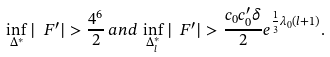<formula> <loc_0><loc_0><loc_500><loc_500>\inf _ { \Delta ^ { * } } | \ F ^ { \prime } | > \frac { 4 ^ { 6 } } { 2 } \, a n d \, \inf _ { \Delta _ { l } ^ { * } } | \ F ^ { \prime } | > \frac { c _ { 0 } c _ { 0 } ^ { \prime } \delta } { 2 } e ^ { \frac { 1 } { 3 } \lambda _ { 0 } ( l + 1 ) } .</formula> 